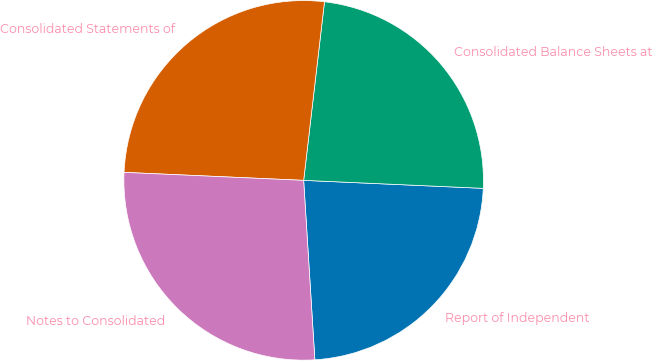Convert chart to OTSL. <chart><loc_0><loc_0><loc_500><loc_500><pie_chart><fcel>Report of Independent<fcel>Consolidated Balance Sheets at<fcel>Consolidated Statements of<fcel>Notes to Consolidated<nl><fcel>23.3%<fcel>23.86%<fcel>26.14%<fcel>26.7%<nl></chart> 